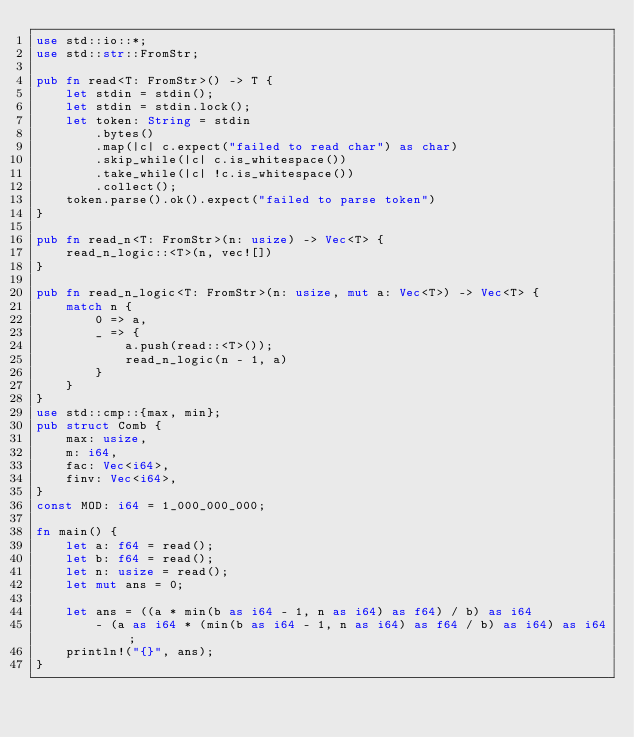Convert code to text. <code><loc_0><loc_0><loc_500><loc_500><_Rust_>use std::io::*;
use std::str::FromStr;

pub fn read<T: FromStr>() -> T {
    let stdin = stdin();
    let stdin = stdin.lock();
    let token: String = stdin
        .bytes()
        .map(|c| c.expect("failed to read char") as char)
        .skip_while(|c| c.is_whitespace())
        .take_while(|c| !c.is_whitespace())
        .collect();
    token.parse().ok().expect("failed to parse token")
}

pub fn read_n<T: FromStr>(n: usize) -> Vec<T> {
    read_n_logic::<T>(n, vec![])
}

pub fn read_n_logic<T: FromStr>(n: usize, mut a: Vec<T>) -> Vec<T> {
    match n {
        0 => a,
        _ => {
            a.push(read::<T>());
            read_n_logic(n - 1, a)
        }
    }
}
use std::cmp::{max, min};
pub struct Comb {
    max: usize,
    m: i64,
    fac: Vec<i64>,
    finv: Vec<i64>,
}
const MOD: i64 = 1_000_000_000;

fn main() {
    let a: f64 = read();
    let b: f64 = read();
    let n: usize = read();
    let mut ans = 0;

    let ans = ((a * min(b as i64 - 1, n as i64) as f64) / b) as i64
        - (a as i64 * (min(b as i64 - 1, n as i64) as f64 / b) as i64) as i64;
    println!("{}", ans);
}
</code> 